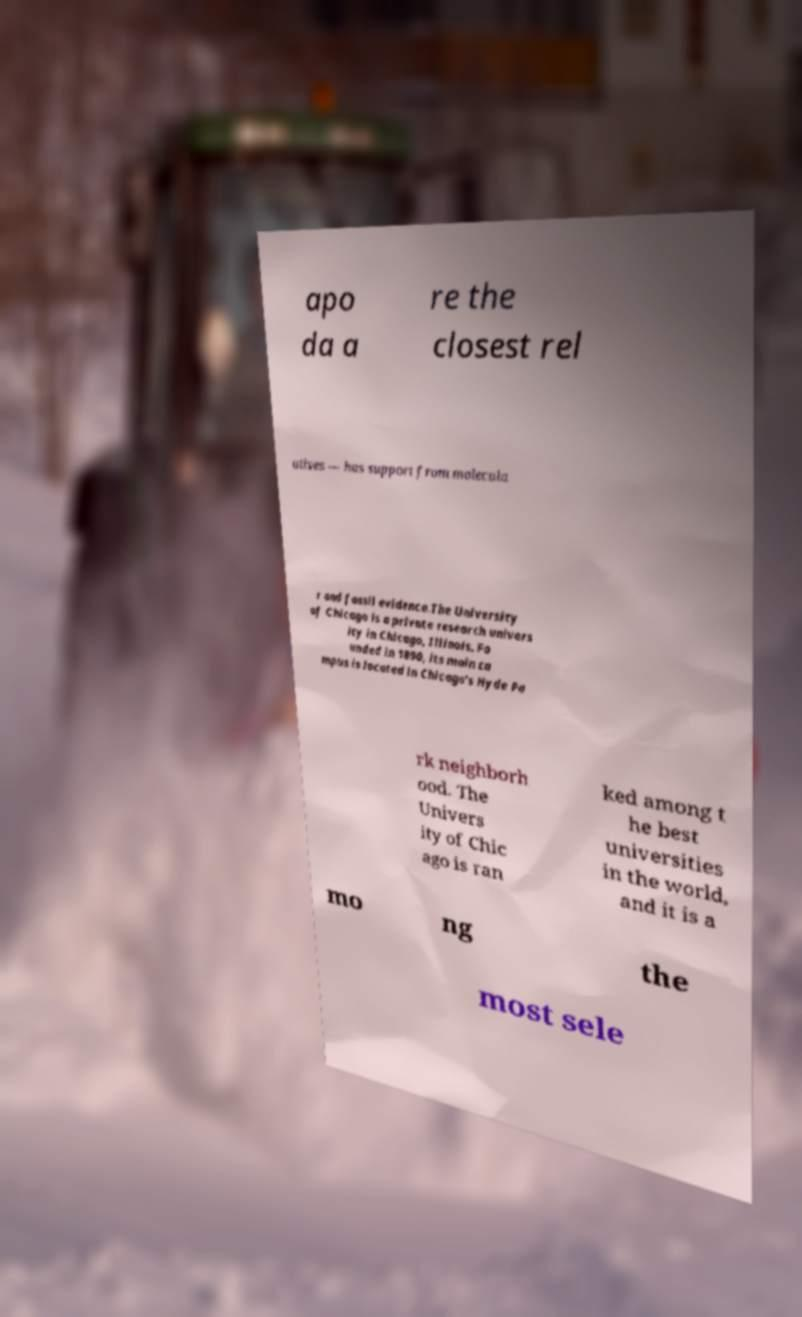Can you read and provide the text displayed in the image?This photo seems to have some interesting text. Can you extract and type it out for me? apo da a re the closest rel atives — has support from molecula r and fossil evidence.The University of Chicago is a private research univers ity in Chicago, Illinois. Fo unded in 1890, its main ca mpus is located in Chicago's Hyde Pa rk neighborh ood. The Univers ity of Chic ago is ran ked among t he best universities in the world, and it is a mo ng the most sele 